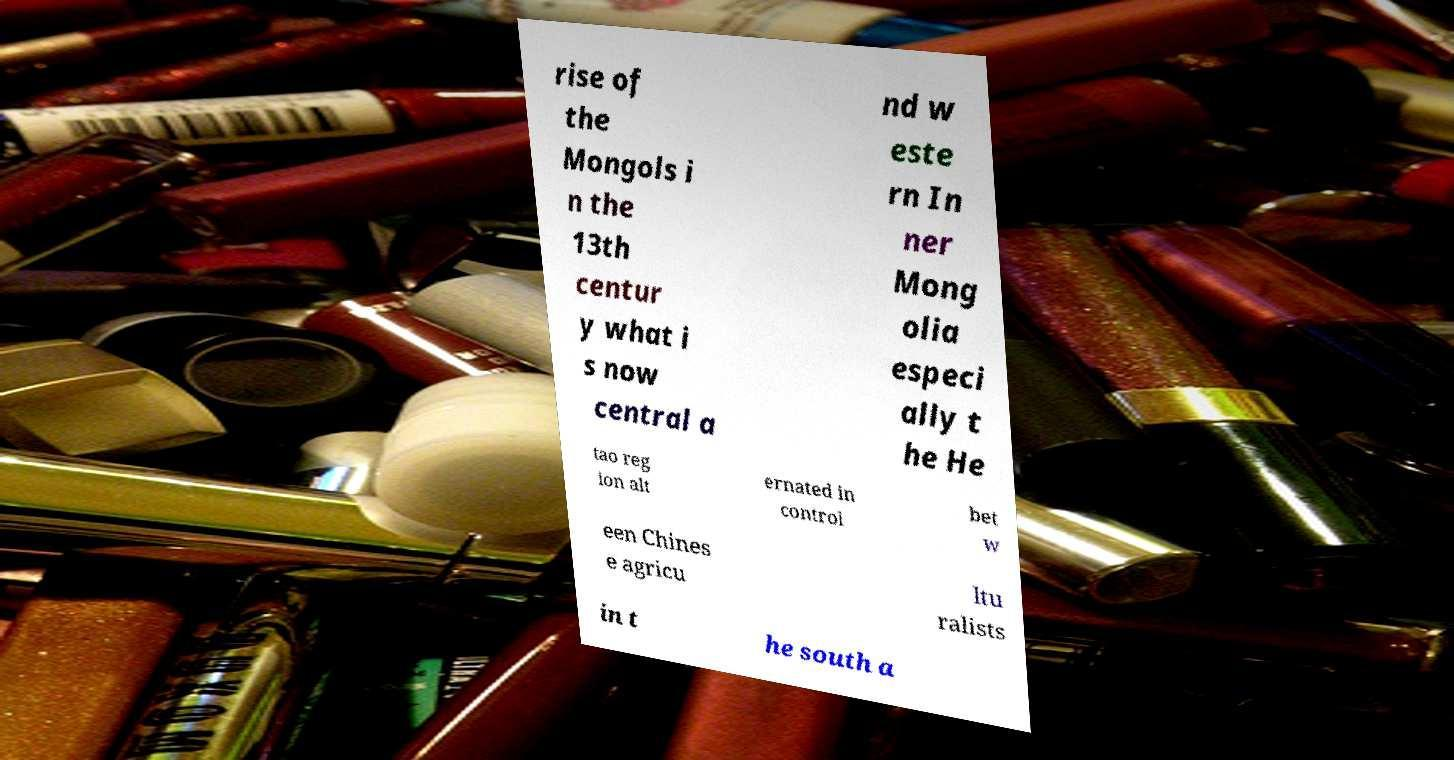Can you read and provide the text displayed in the image?This photo seems to have some interesting text. Can you extract and type it out for me? rise of the Mongols i n the 13th centur y what i s now central a nd w este rn In ner Mong olia especi ally t he He tao reg ion alt ernated in control bet w een Chines e agricu ltu ralists in t he south a 